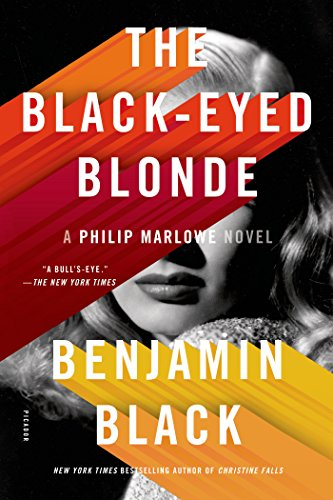What year was this book published? This book, 'The Black-Eyed Blonde: A Philip Marlowe Novel,' was published in 2014. 